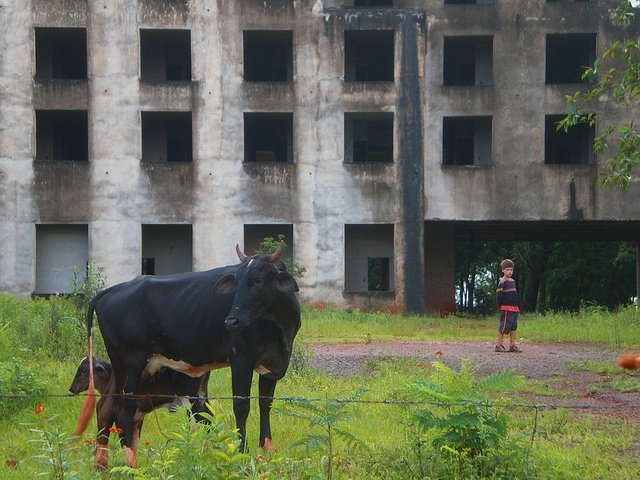Describe the objects in this image and their specific colors. I can see cow in lightgray, black, gray, and olive tones, cow in lightgray, black, maroon, olive, and gray tones, and people in lightgray, black, brown, and gray tones in this image. 